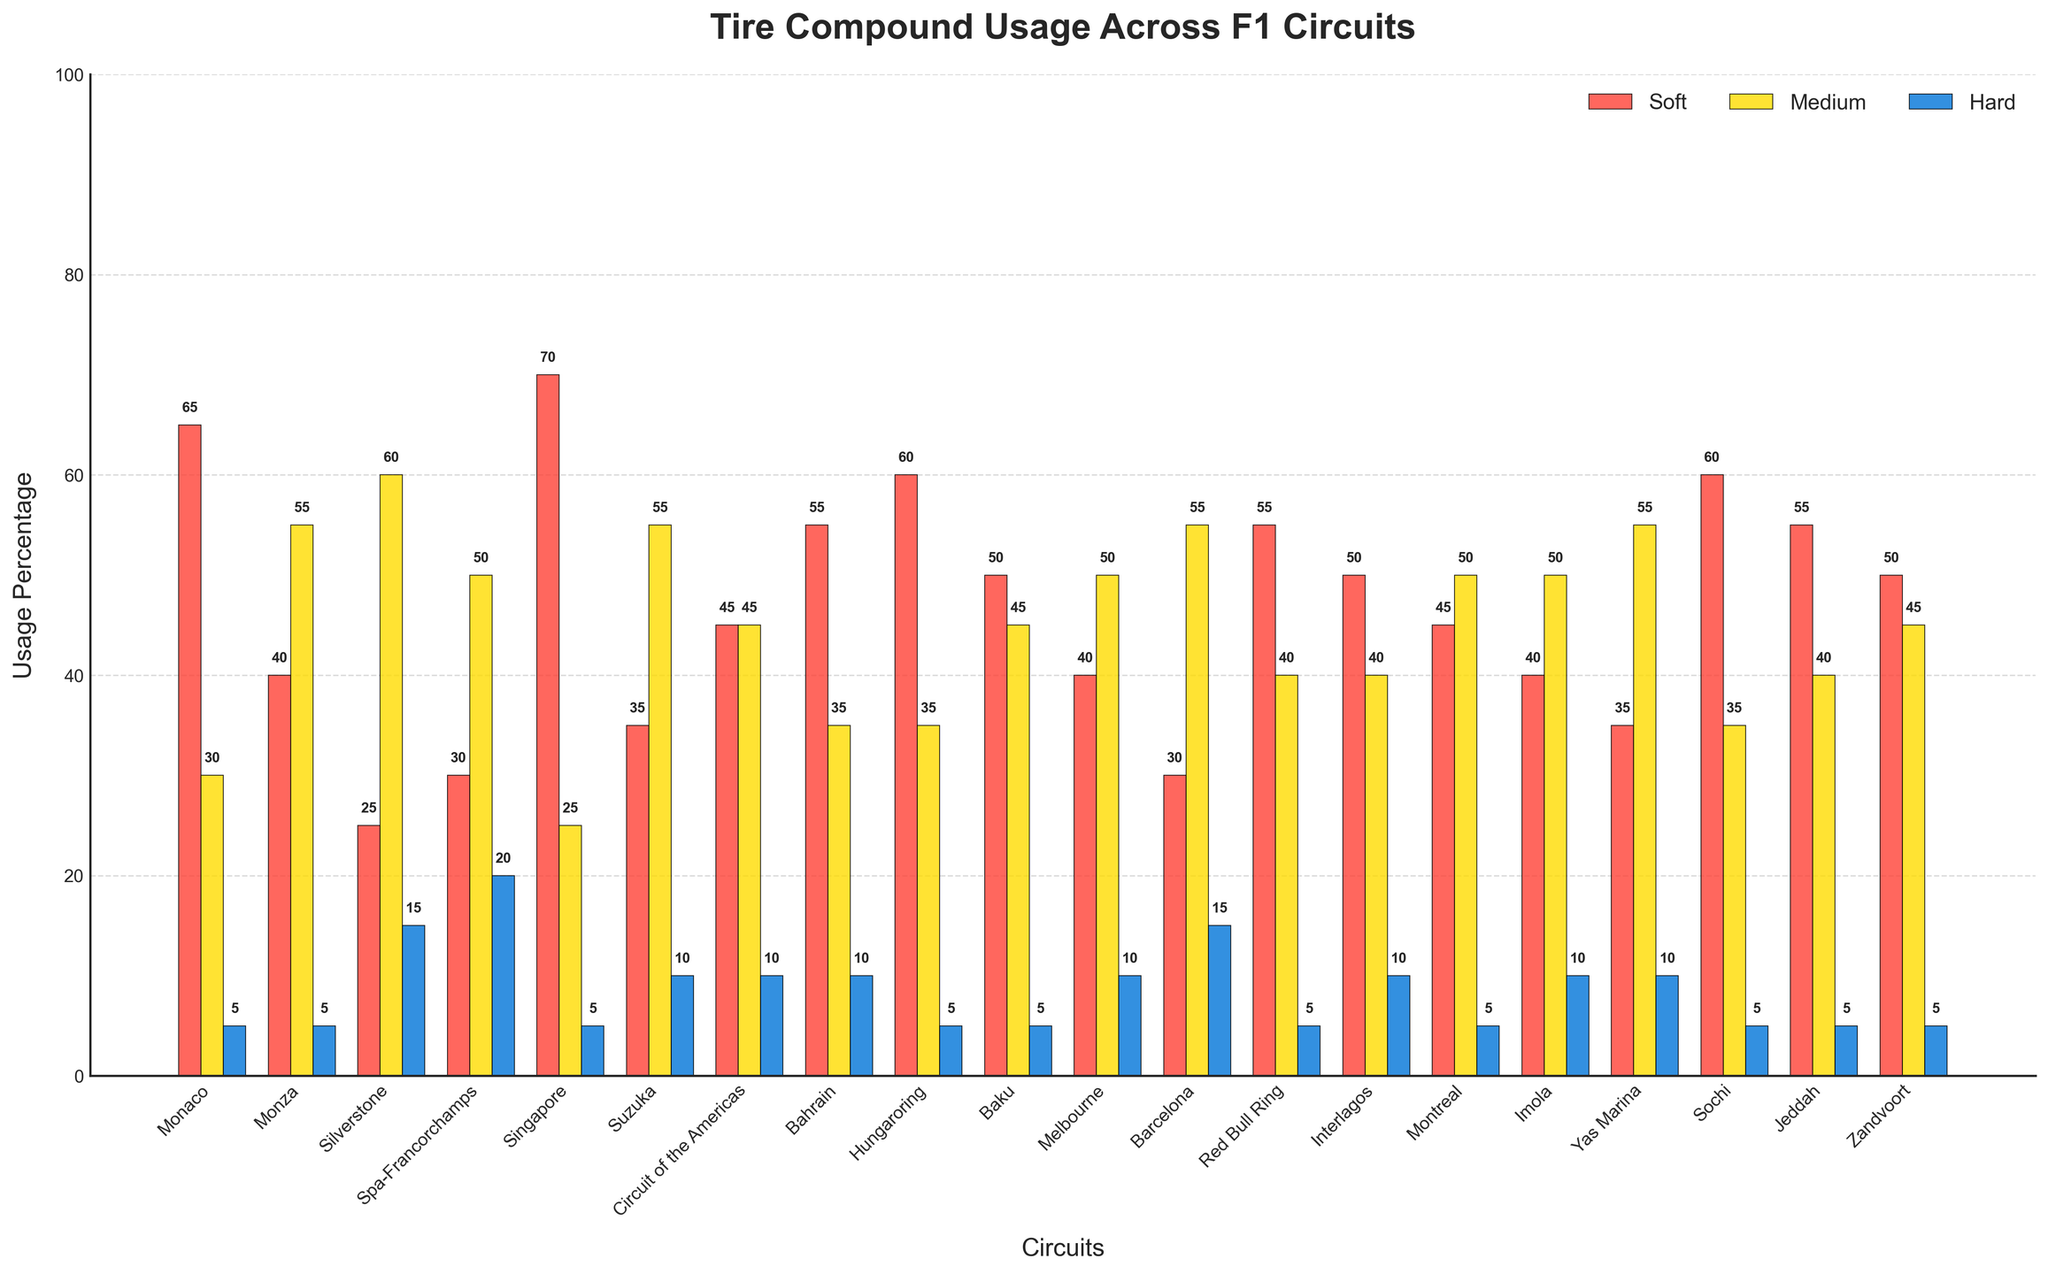Which circuit has the highest usage of soft tires? Look at the highest bar in the red group.
Answer: Singapore Which compounds are used most and least at Monza? Compare the heights of the bars for Monza. The highest bar (yellow) represents medium tires, and the lowest bar (blue) represents hard tires.
Answer: Medium (most), Hard (least) What is the sum of medium tire usage percentages for Monza and Suzuka? Add the medium tire usage percentages of Monza (55) and Suzuka (55).
Answer: 110 Which circuit has an equal usage percentage of soft and medium tires? Look for a circuit where the heights of the red and yellow bars are the same.
Answer: Circuit of the Americas Which circuit has the least preference for hard tires? Find the circuit with the smallest blue bar.
Answer: Monaco Is soft tire usage generally higher or lower compared to medium tire usage? Look at the overall height comparison between red and yellow bars across circuits.
Answer: Generally lower What is the total usage percentage of hard tires at Silverstone and Spa-Francorchamps? Add the hard tire usage percentages of Silverstone (15) and Spa-Francorchamps (20).
Answer: 35 Which circuit has the highest sum of tire usage across all compounds? Calculate the sum of the heights (soft + medium + hard) for all circuits and find the highest.
Answer: Singapore Compare the usage of soft and medium tires at Baku. Which is higher? Compare the heights of the red and yellow bars for Baku.
Answer: Soft What is the difference between the highest and lowest medium tire usage? Identify the highest (Yas Marina and others at 55) and lowest (Singapore at 25) medium tire usage percentages and calculate the difference (55 - 25).
Answer: 30 